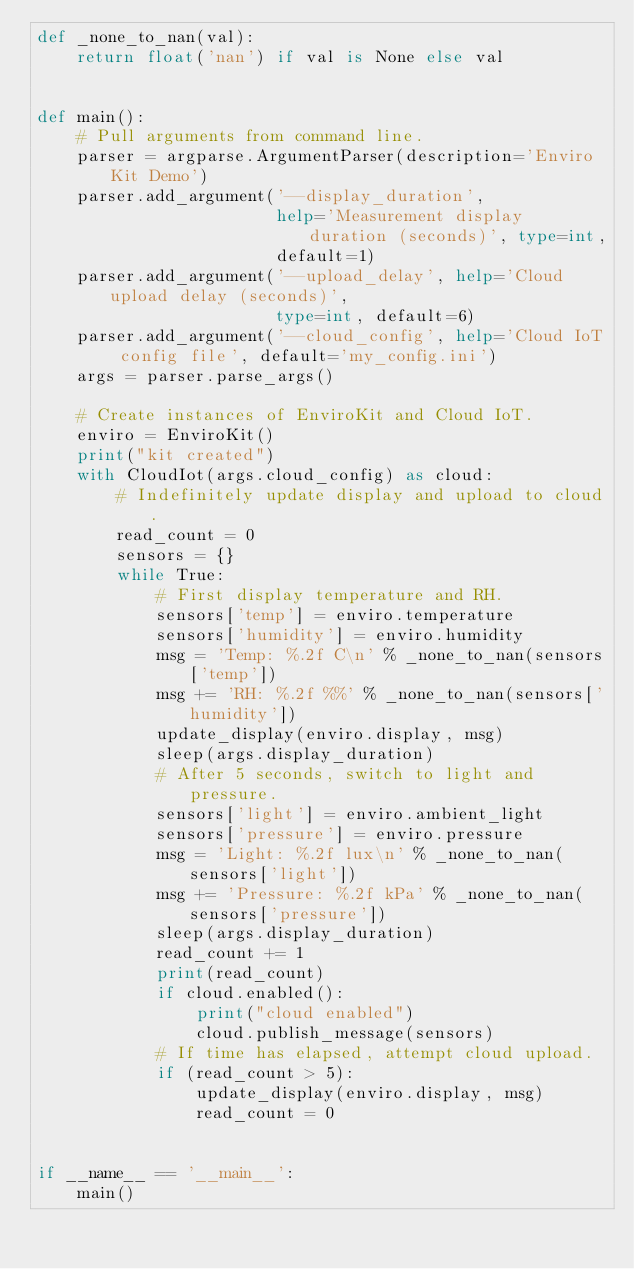<code> <loc_0><loc_0><loc_500><loc_500><_Python_>def _none_to_nan(val):
    return float('nan') if val is None else val


def main():
    # Pull arguments from command line.
    parser = argparse.ArgumentParser(description='Enviro Kit Demo')
    parser.add_argument('--display_duration',
                        help='Measurement display duration (seconds)', type=int,
                        default=1)
    parser.add_argument('--upload_delay', help='Cloud upload delay (seconds)',
                        type=int, default=6)
    parser.add_argument('--cloud_config', help='Cloud IoT config file', default='my_config.ini')
    args = parser.parse_args()

    # Create instances of EnviroKit and Cloud IoT.
    enviro = EnviroKit()
    print("kit created")
    with CloudIot(args.cloud_config) as cloud:
        # Indefinitely update display and upload to cloud.
        read_count = 0
        sensors = {}
        while True:
            # First display temperature and RH.
            sensors['temp'] = enviro.temperature
            sensors['humidity'] = enviro.humidity
            msg = 'Temp: %.2f C\n' % _none_to_nan(sensors['temp'])
            msg += 'RH: %.2f %%' % _none_to_nan(sensors['humidity'])
            update_display(enviro.display, msg)
            sleep(args.display_duration)
            # After 5 seconds, switch to light and pressure.
            sensors['light'] = enviro.ambient_light
            sensors['pressure'] = enviro.pressure
            msg = 'Light: %.2f lux\n' % _none_to_nan(sensors['light'])
            msg += 'Pressure: %.2f kPa' % _none_to_nan(sensors['pressure'])
            sleep(args.display_duration)
            read_count += 1
            print(read_count)
            if cloud.enabled():
                print("cloud enabled")
                cloud.publish_message(sensors)
            # If time has elapsed, attempt cloud upload.
            if (read_count > 5):
                update_display(enviro.display, msg)
                read_count = 0


if __name__ == '__main__':
    main()
</code> 